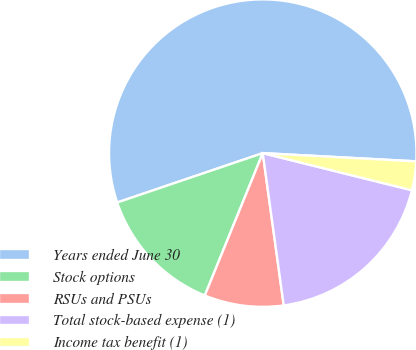Convert chart to OTSL. <chart><loc_0><loc_0><loc_500><loc_500><pie_chart><fcel>Years ended June 30<fcel>Stock options<fcel>RSUs and PSUs<fcel>Total stock-based expense (1)<fcel>Income tax benefit (1)<nl><fcel>56.06%<fcel>13.64%<fcel>8.33%<fcel>18.94%<fcel>3.03%<nl></chart> 